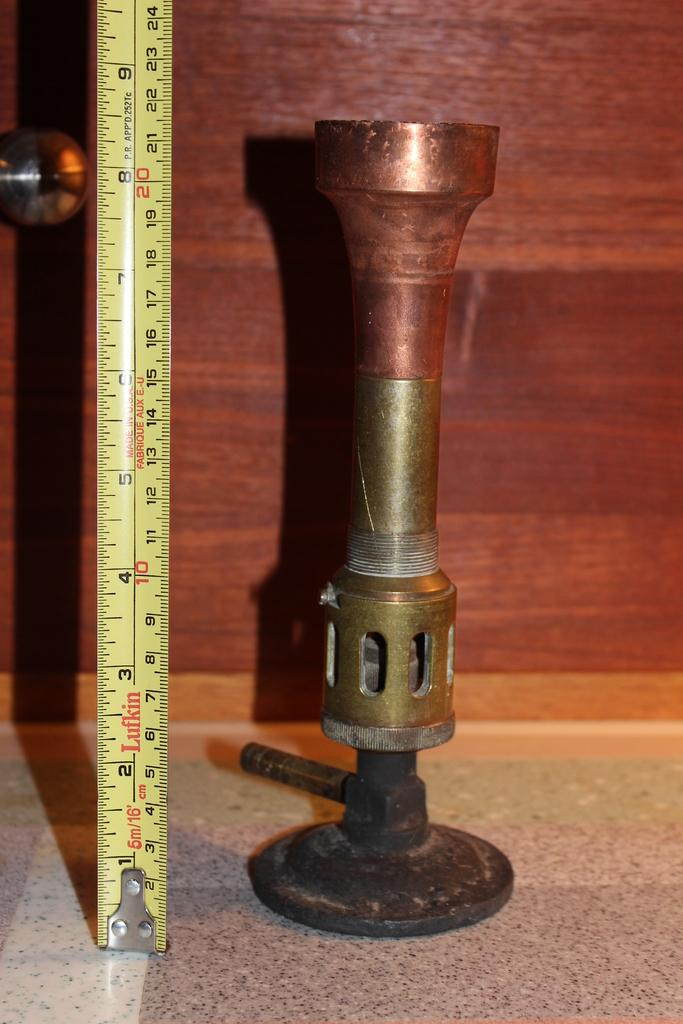<image>
Describe the image concisely. A metal object measuring more than 20 inches when standing on end. 